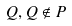<formula> <loc_0><loc_0><loc_500><loc_500>Q , Q \notin P</formula> 